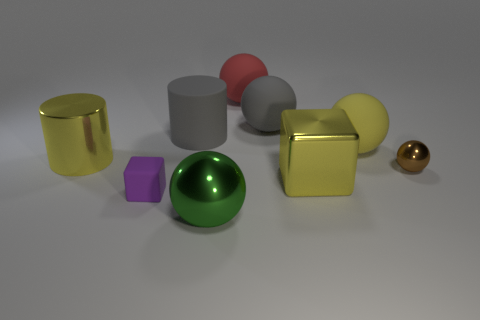Subtract all small metallic spheres. How many spheres are left? 4 Subtract all purple spheres. Subtract all yellow cylinders. How many spheres are left? 5 Subtract all cubes. How many objects are left? 7 Add 5 large gray objects. How many large gray objects are left? 7 Add 6 large rubber spheres. How many large rubber spheres exist? 9 Subtract 1 yellow cylinders. How many objects are left? 8 Subtract all purple blocks. Subtract all large red rubber spheres. How many objects are left? 7 